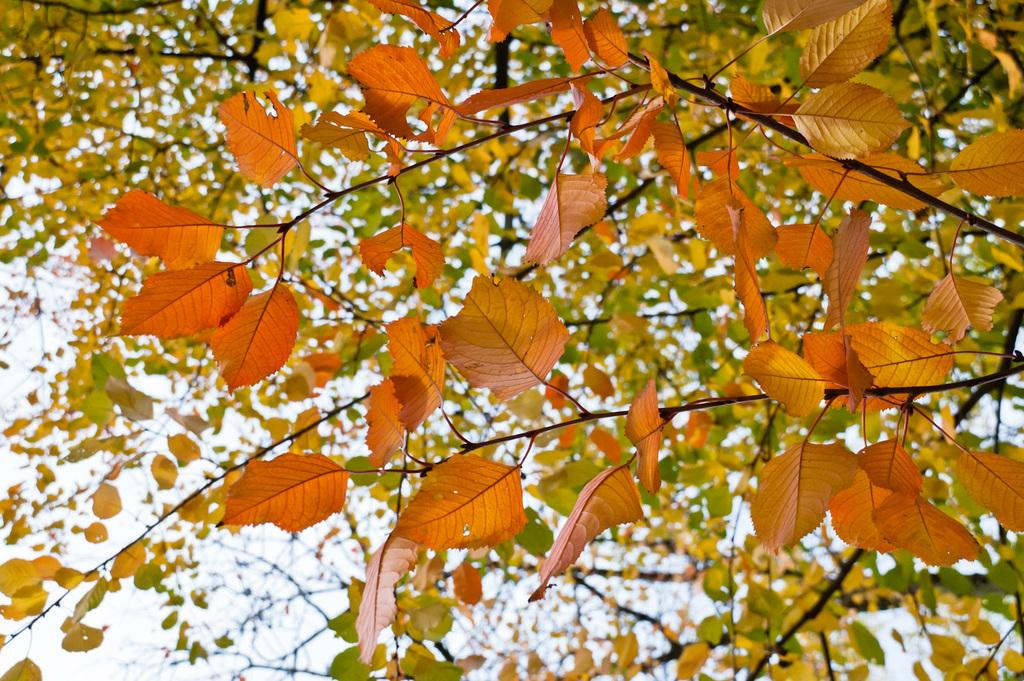What type of natural elements can be seen in the image? There are leaves in the image. What colors are the leaves in the image? The leaves are in orange, green, and yellow colors. What is the color of the sky in the image? The sky is in white color. Where is the grandfather sitting in the image? There is no grandfather present in the image; it only features leaves and a sky. 